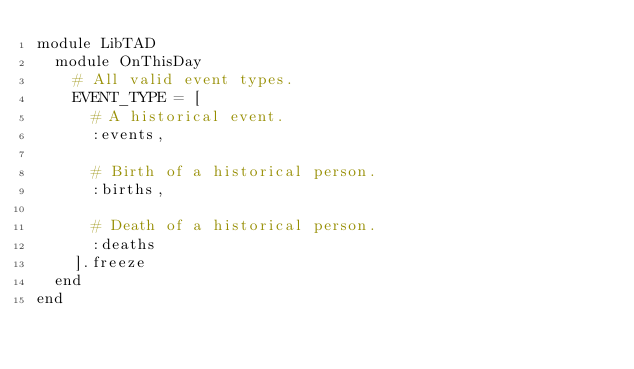<code> <loc_0><loc_0><loc_500><loc_500><_Ruby_>module LibTAD
  module OnThisDay
    # All valid event types.
    EVENT_TYPE = [
      # A historical event.
      :events,

      # Birth of a historical person.
      :births,

      # Death of a historical person.
      :deaths
    ].freeze
  end
end
</code> 